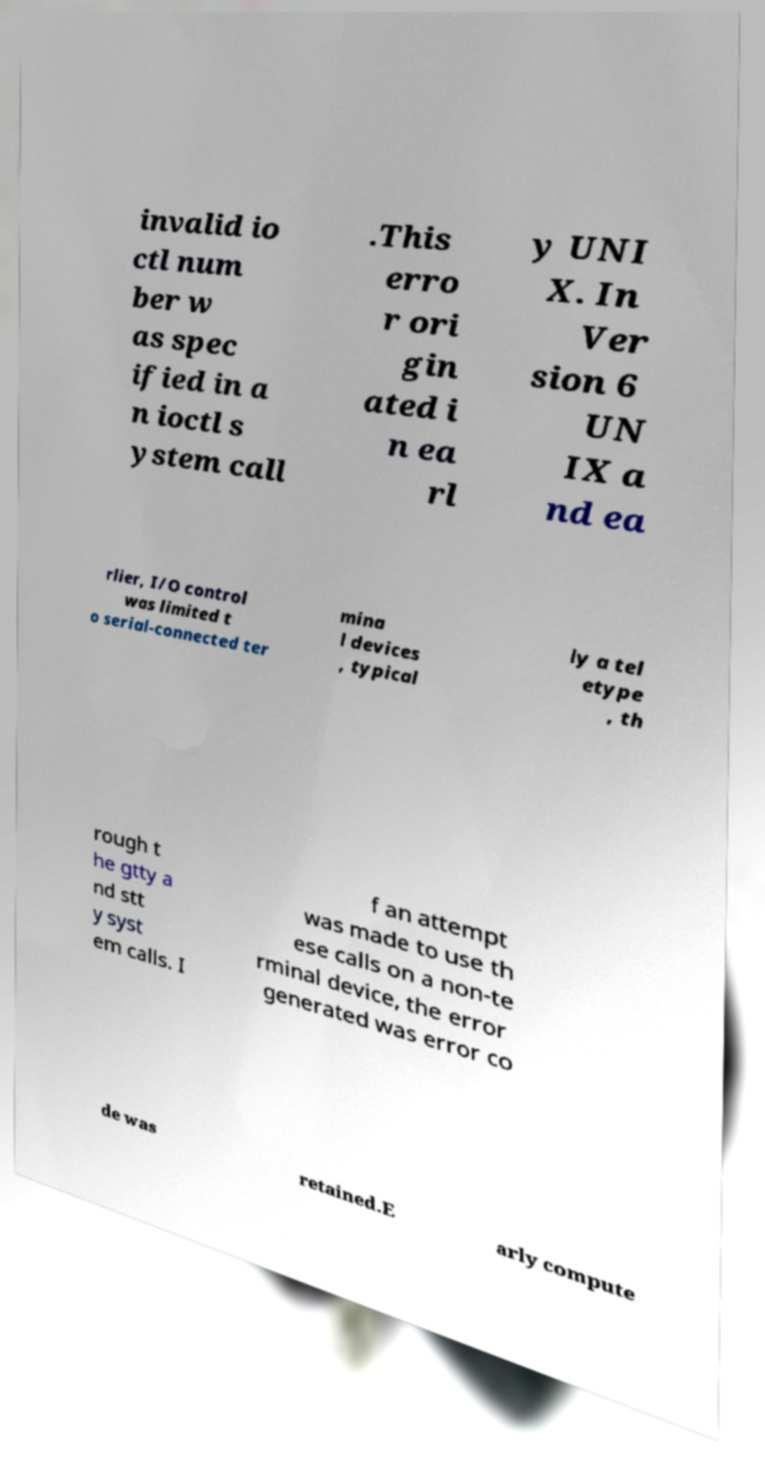Could you assist in decoding the text presented in this image and type it out clearly? invalid io ctl num ber w as spec ified in a n ioctl s ystem call .This erro r ori gin ated i n ea rl y UNI X. In Ver sion 6 UN IX a nd ea rlier, I/O control was limited t o serial-connected ter mina l devices , typical ly a tel etype , th rough t he gtty a nd stt y syst em calls. I f an attempt was made to use th ese calls on a non-te rminal device, the error generated was error co de was retained.E arly compute 